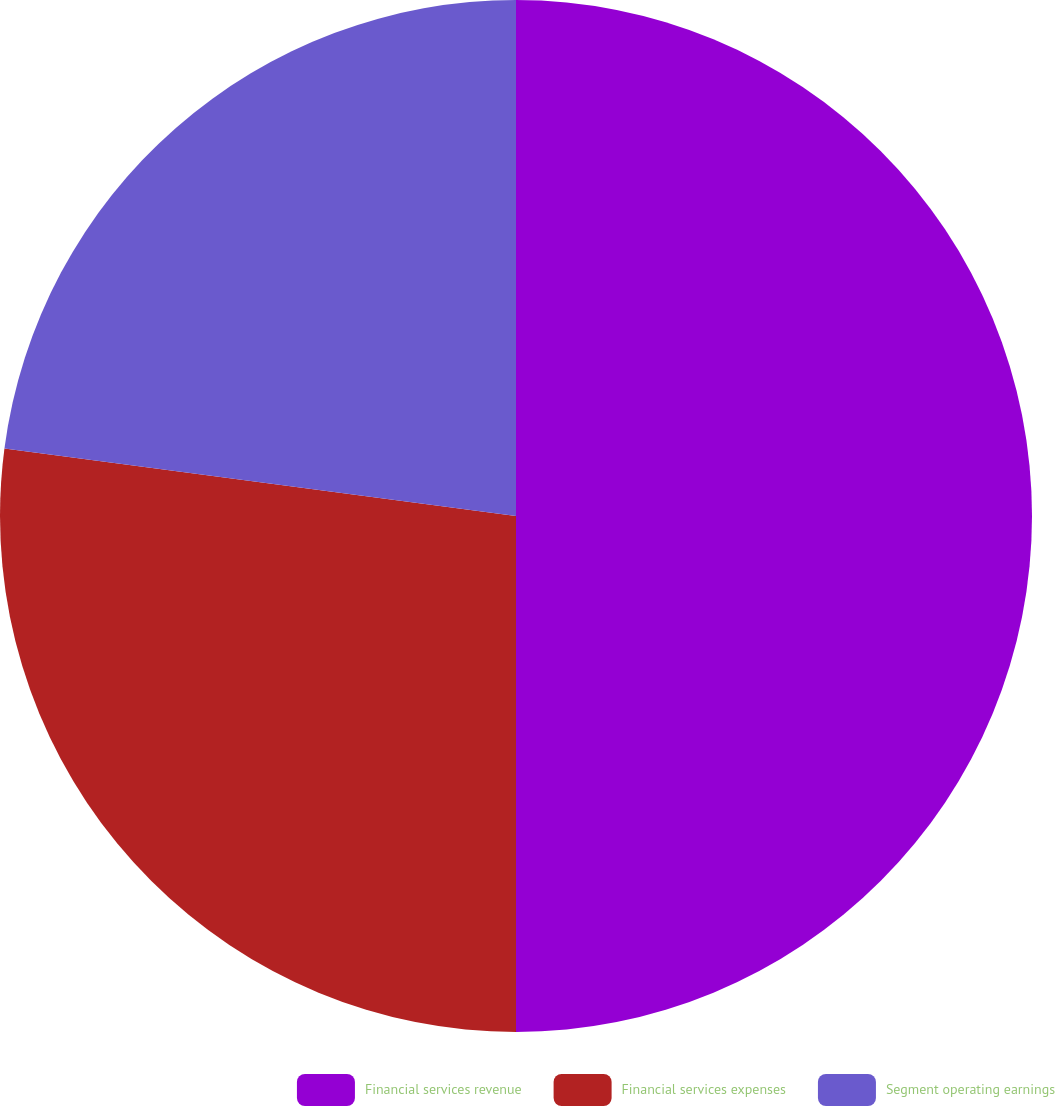<chart> <loc_0><loc_0><loc_500><loc_500><pie_chart><fcel>Financial services revenue<fcel>Financial services expenses<fcel>Segment operating earnings<nl><fcel>50.0%<fcel>27.09%<fcel>22.91%<nl></chart> 